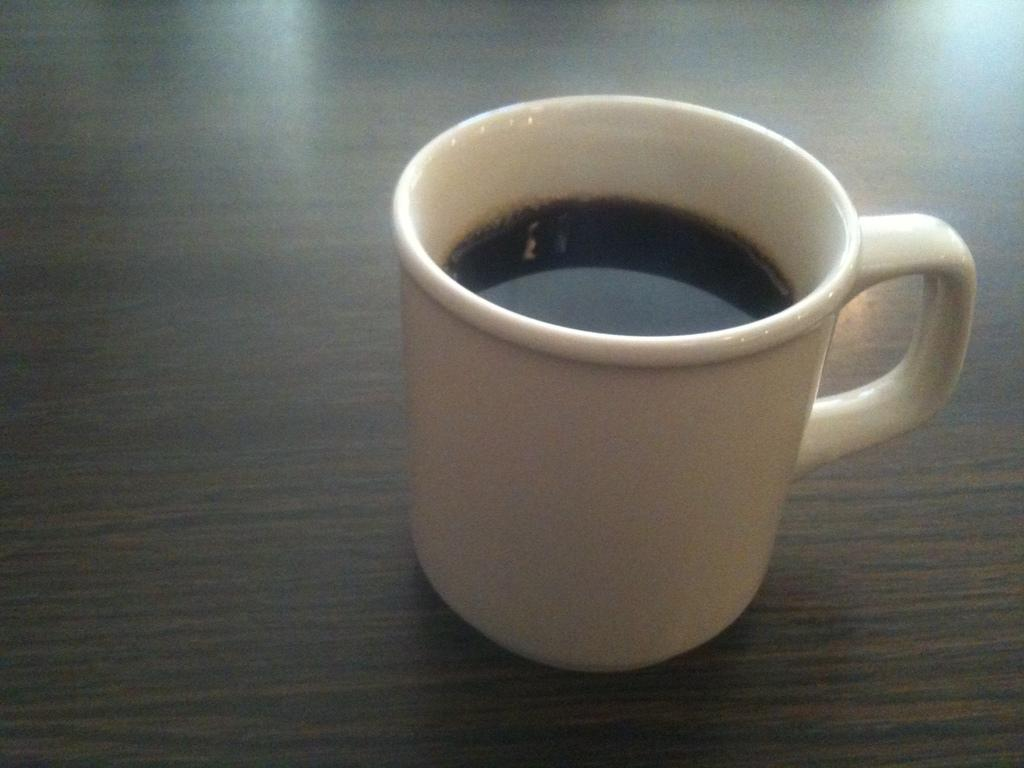What is the main object in the image? There is a tea cup in the image. What is the tea cup placed on? The tea cup is placed on a wooden surface. Can you see any squirrels wearing trousers in the image? There are no squirrels or trousers present in the image. 